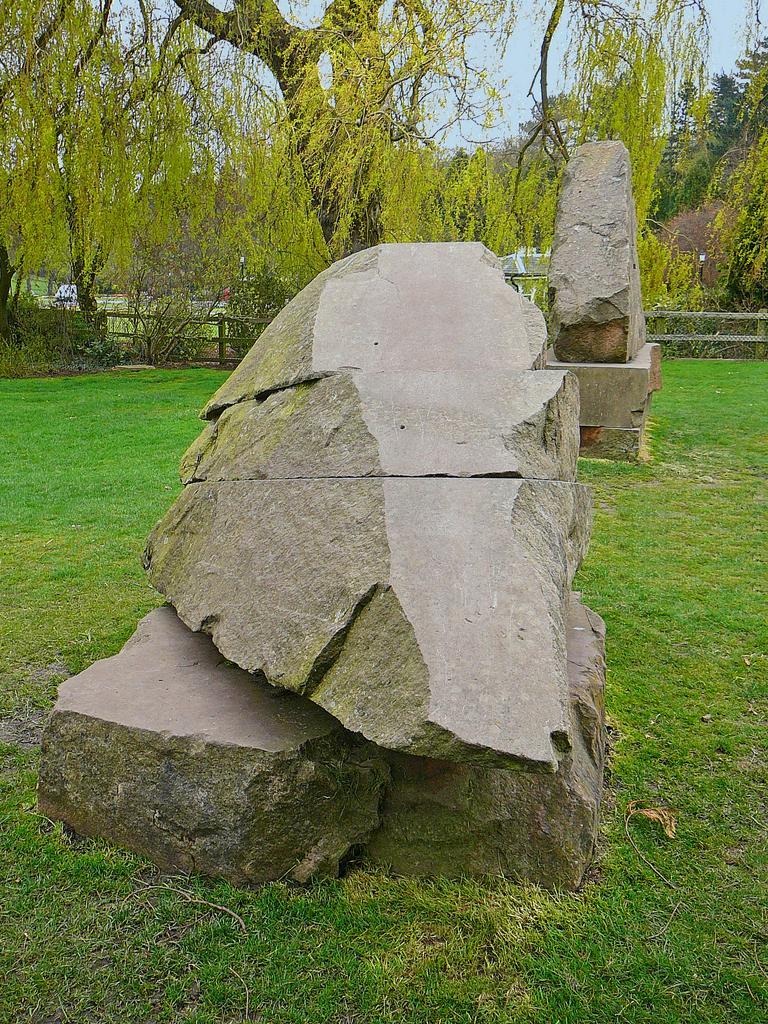How would you summarize this image in a sentence or two? In this picture we can see the grass, stones, fence, trees and in the background we can see the sky. 